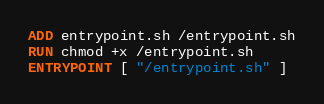<code> <loc_0><loc_0><loc_500><loc_500><_Dockerfile_>
ADD entrypoint.sh /entrypoint.sh
RUN chmod +x /entrypoint.sh
ENTRYPOINT [ "/entrypoint.sh" ]
</code> 